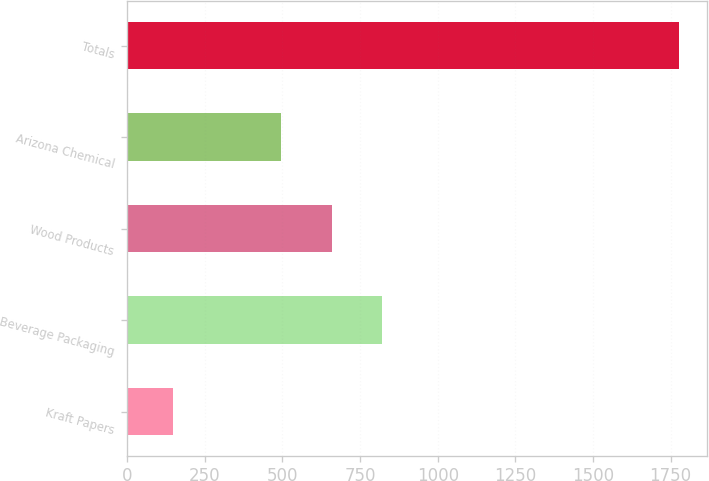<chart> <loc_0><loc_0><loc_500><loc_500><bar_chart><fcel>Kraft Papers<fcel>Beverage Packaging<fcel>Wood Products<fcel>Arizona Chemical<fcel>Totals<nl><fcel>148<fcel>822<fcel>659<fcel>496<fcel>1778<nl></chart> 